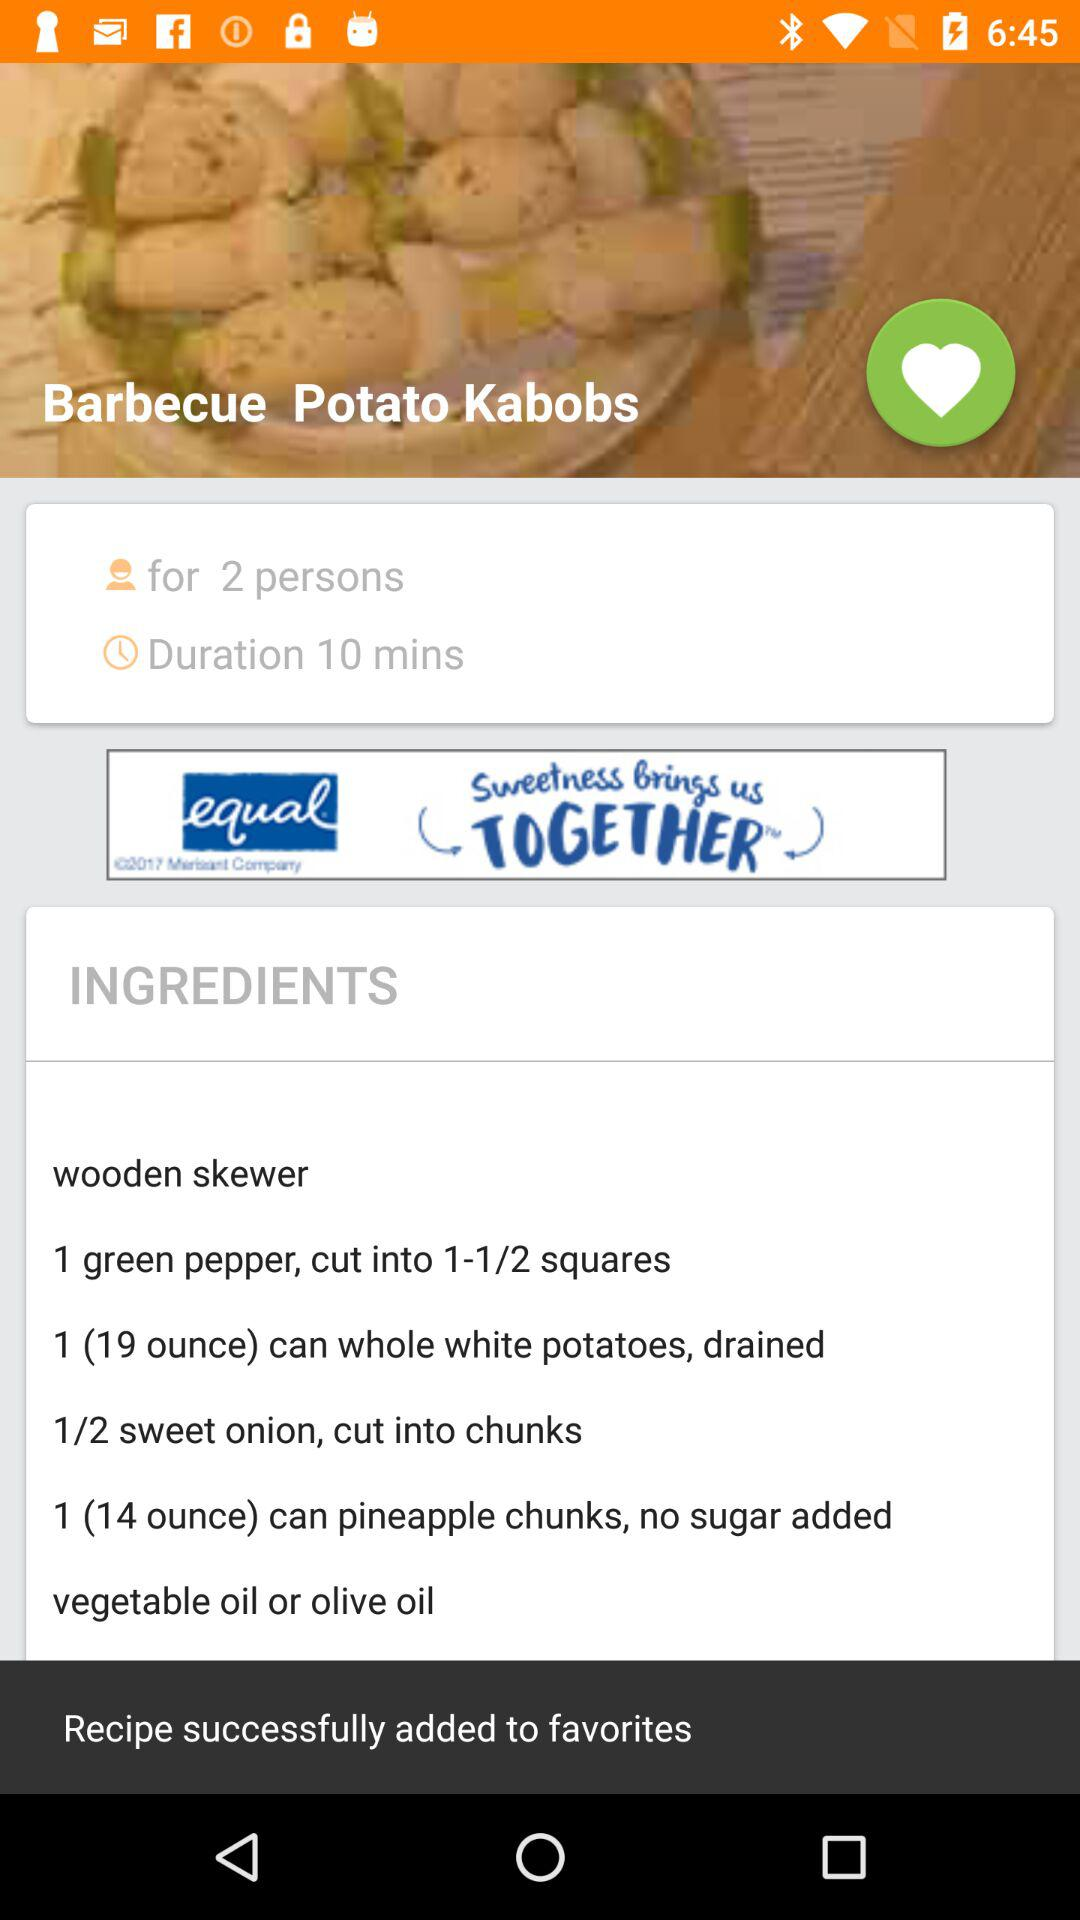How many ingredients does the recipe require?
Answer the question using a single word or phrase. 6 